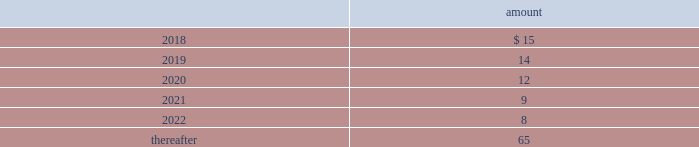Deposits 2014deposits include escrow funds and certain other deposits held in trust .
The company includes cash deposits in other current assets .
Deferred compensation obligations 2014the company 2019s deferred compensation plans allow participants to defer certain cash compensation into notional investment accounts .
The company includes such plans in other long-term liabilities .
The value of the company 2019s deferred compensation obligations is based on the market value of the participants 2019 notional investment accounts .
The notional investments are comprised primarily of mutual funds , which are based on observable market prices .
Mark-to-market derivative asset and liability 2014the company utilizes fixed-to-floating interest-rate swaps , typically designated as fair-value hedges , to achieve a targeted level of variable-rate debt as a percentage of total debt .
The company also employs derivative financial instruments in the form of variable-to-fixed interest rate swaps and forward starting interest rate swaps , classified as economic hedges and cash flow hedges , respectively , in order to fix the interest cost on existing or forecasted debt .
The company uses a calculation of future cash inflows and estimated future outflows , which are discounted , to determine the current fair value .
Additional inputs to the present value calculation include the contract terms , counterparty credit risk , interest rates and market volatility .
Other investments 2014other investments primarily represent money market funds used for active employee benefits .
The company includes other investments in other current assets .
Note 18 : leases the company has entered into operating leases involving certain facilities and equipment .
Rental expenses under operating leases were $ 29 million , $ 24 million and $ 21 million for the years ended december 31 , 2017 , 2016 and 2015 , respectively .
The operating leases for facilities will expire over the next 25 years and the operating leases for equipment will expire over the next 5 years .
Certain operating leases have renewal options ranging from one to five years .
The minimum annual future rental commitment under operating leases that have initial or remaining non-cancelable lease terms over the next 5 years and thereafter are as follows: .
The company has a series of agreements with various public entities ( the 201cpartners 201d ) to establish certain joint ventures , commonly referred to as 201cpublic-private partnerships . 201d under the public-private partnerships , the company constructed utility plant , financed by the company and the partners constructed utility plant ( connected to the company 2019s property ) , financed by the partners .
The company agreed to transfer and convey some of its real and personal property to the partners in exchange for an equal principal amount of industrial development bonds ( 201cidbs 201d ) , issued by the partners under a state industrial development bond and commercial development act .
The company leased back the total facilities , including portions funded by both the company and the partners , under leases for a period of 40 years .
The leases related to the portion of the facilities funded by the company have required payments from the company to the partners that approximate the payments required by the terms of the idbs from the partners to the company ( as the holder of the idbs ) .
As the ownership of the portion of the facilities constructed by the .
What were the average operating rental expenses from 2015 to 2017 in millions? 
Rationale: the average is the sum of the periods divided by the count
Computations: (((29 + 24) + 21) / 3)
Answer: 24.66667. 